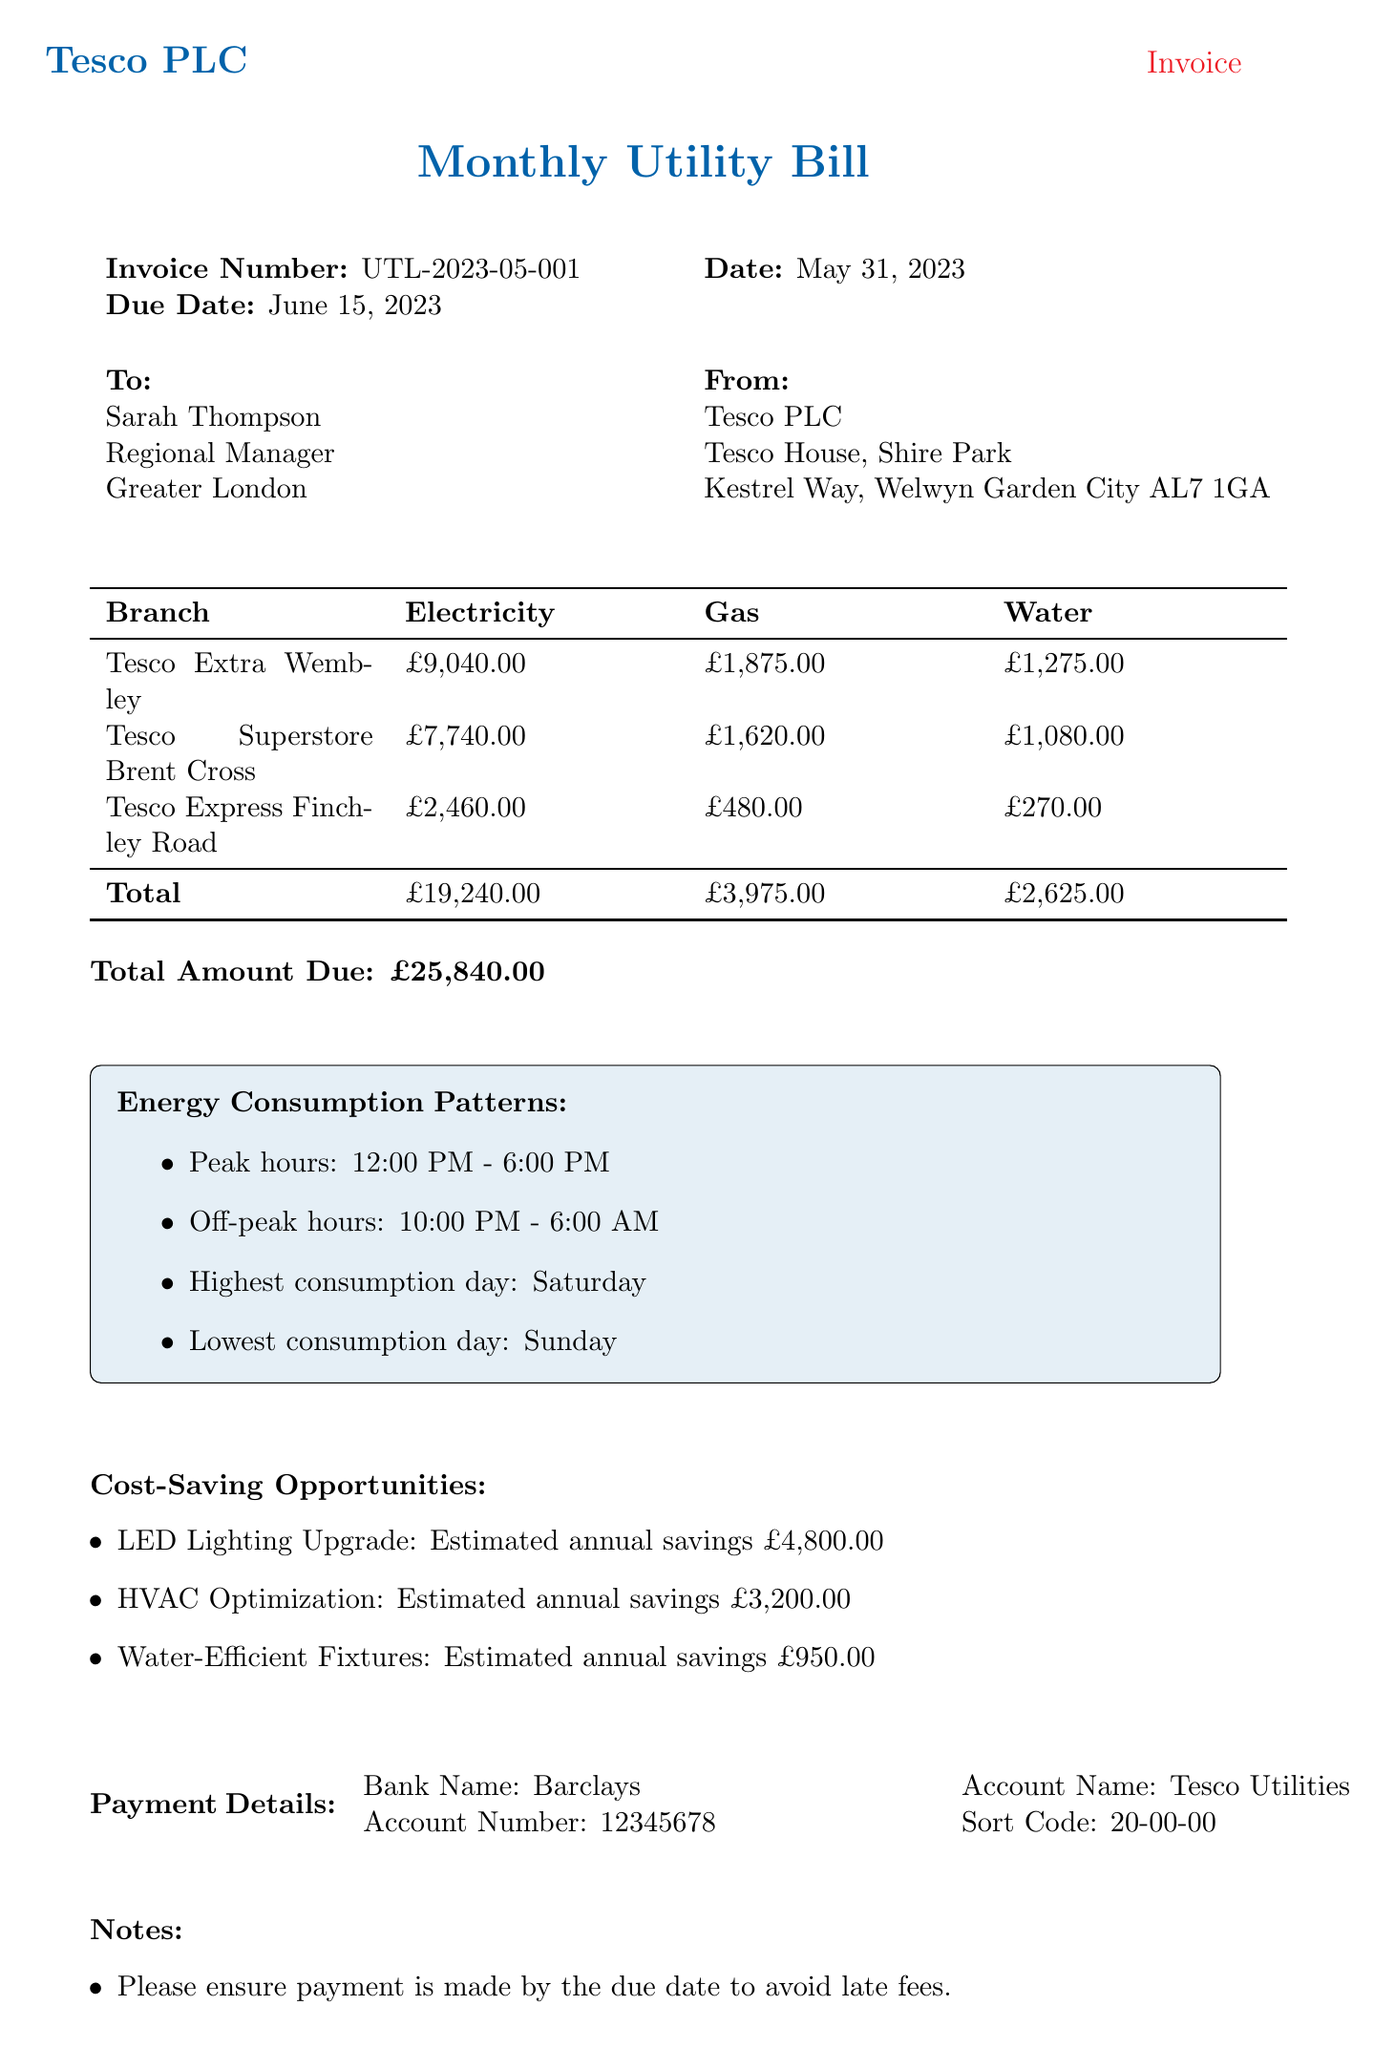what is the invoice number? The invoice number is clearly stated in the invoice header section, which is UTL-2023-05-001.
Answer: UTL-2023-05-001 what is the total amount due? The total amount due is mentioned at the end of the invoice summary, which sums up all utility costs.
Answer: £25,840.00 how much did Tesco Extra Wembley spend on electricity? The invoice lists the individual branch costs, showing Tesco Extra Wembley spent £9,040.00 on electricity.
Answer: £9,040.00 what is the estimated annual savings from LED Lighting Upgrade? The document lists the cost-saving opportunities, indicating that the estimated annual savings from LED Lighting Upgrade is £4,800.00.
Answer: £4,800.00 which branch had the highest gas consumption? By comparing the gas consumption figures provided for each branch, Tesco Extra Wembley has the highest gas consumption of 12,500.
Answer: Tesco Extra Wembley which day is noted as the highest consumption day? The energy consumption patterns section clearly states that Saturday is the highest consumption day.
Answer: Saturday what is the gas cost for Tesco Superstore Brent Cross? The invoice specifies the cost attributed to gas for Tesco Superstore Brent Cross as £1,620.00.
Answer: £1,620.00 what is the account name for payment details? The payment details section of the document lists the associated account name as Tesco Utilities.
Answer: Tesco Utilities 